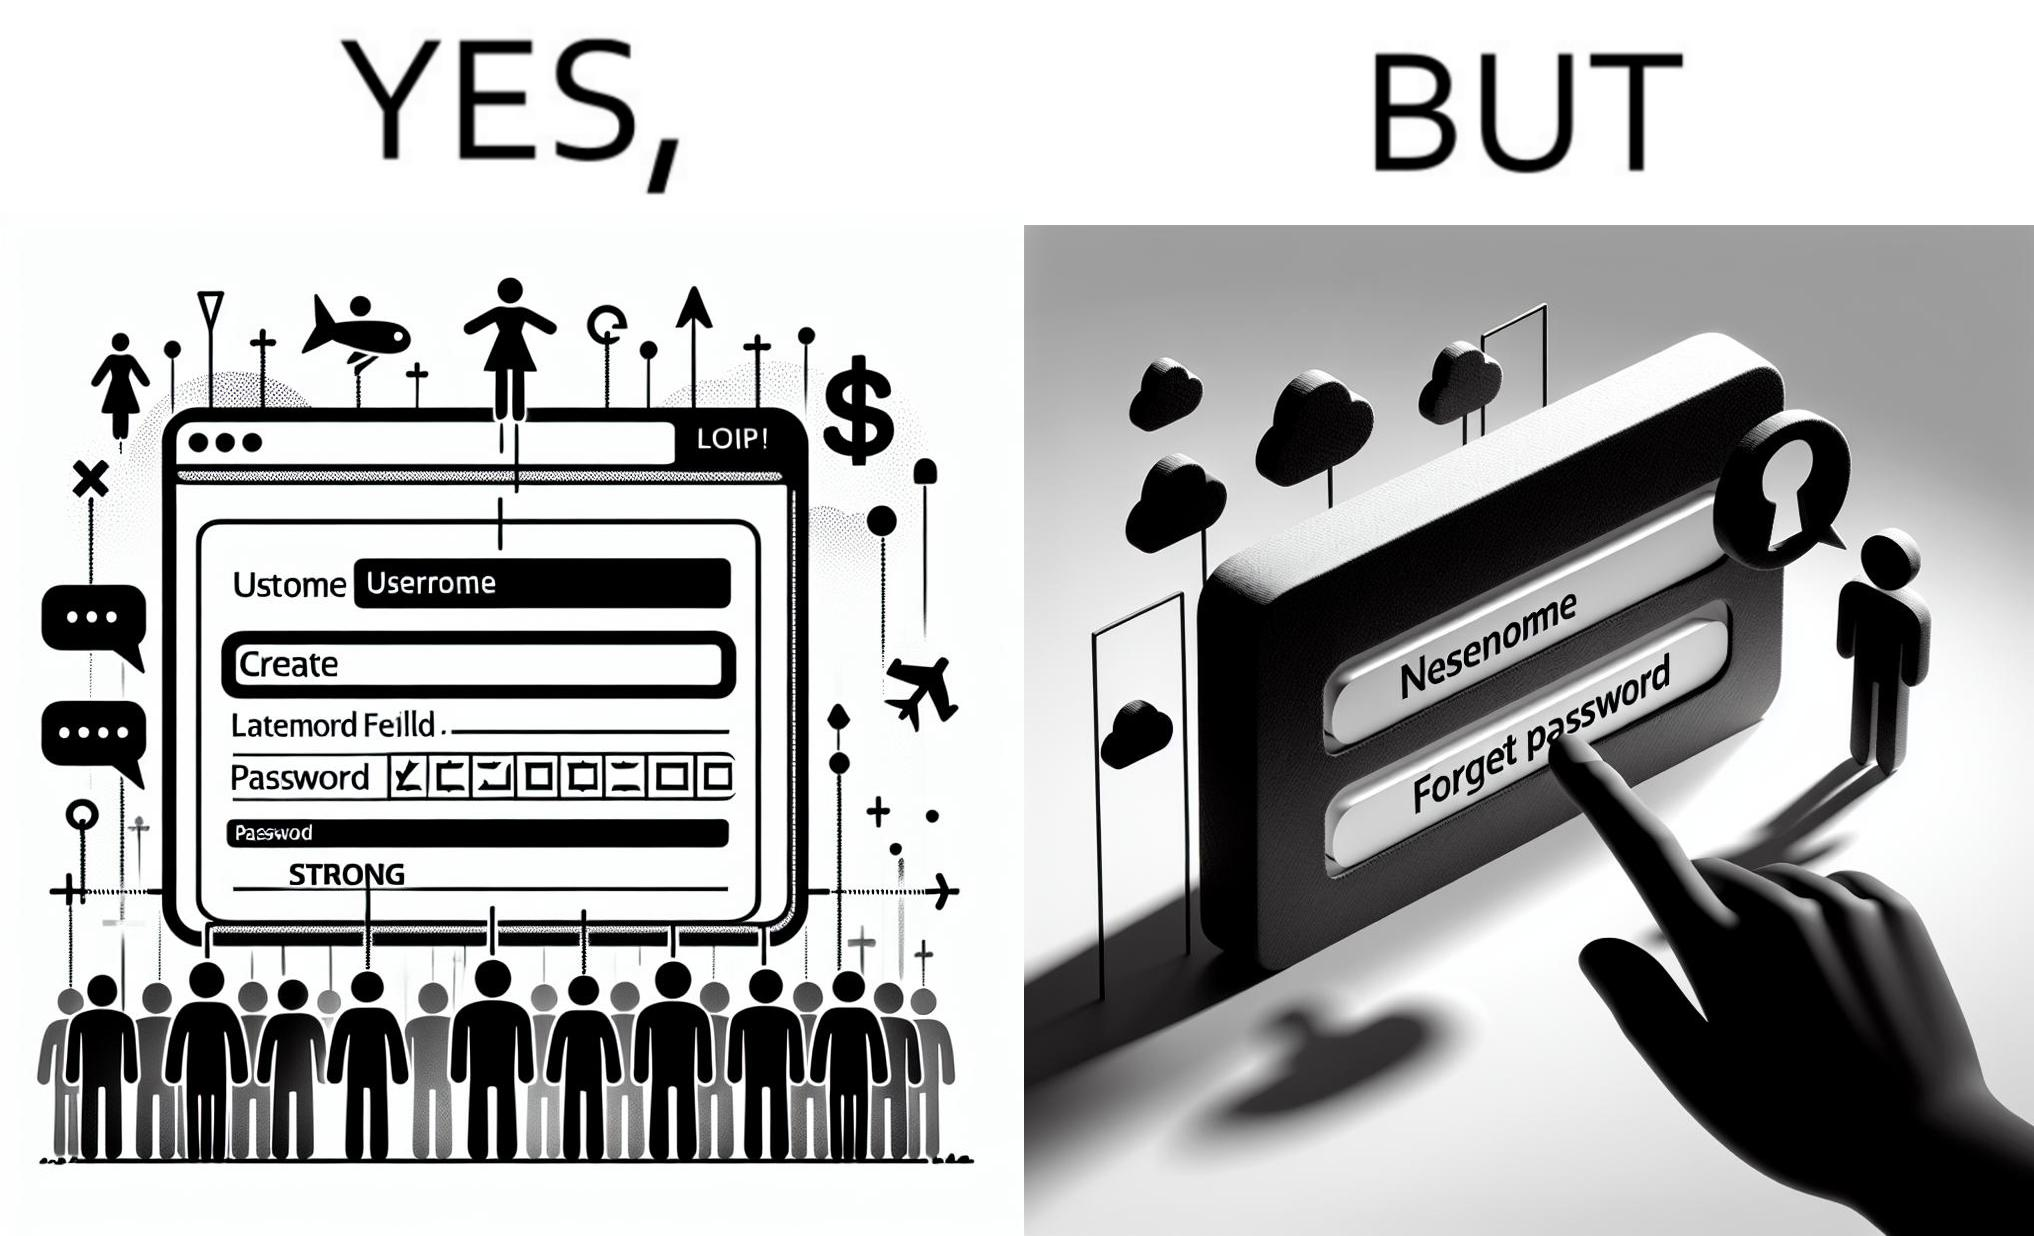Does this image contain satire or humor? Yes, this image is satirical. 